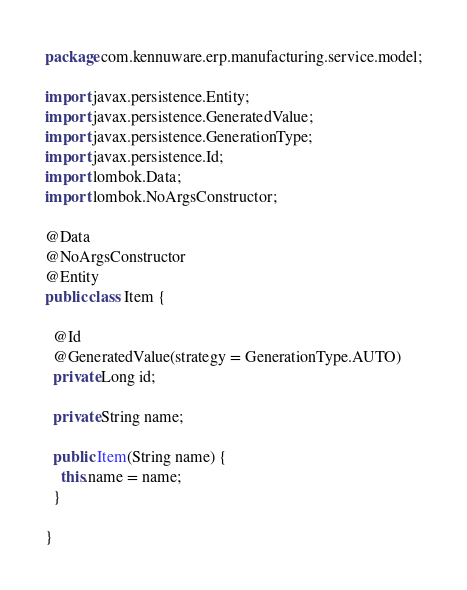<code> <loc_0><loc_0><loc_500><loc_500><_Java_>package com.kennuware.erp.manufacturing.service.model;

import javax.persistence.Entity;
import javax.persistence.GeneratedValue;
import javax.persistence.GenerationType;
import javax.persistence.Id;
import lombok.Data;
import lombok.NoArgsConstructor;

@Data
@NoArgsConstructor
@Entity
public class Item {

  @Id
  @GeneratedValue(strategy = GenerationType.AUTO)
  private Long id;

  private String name;

  public Item(String name) {
    this.name = name;
  }

}
</code> 